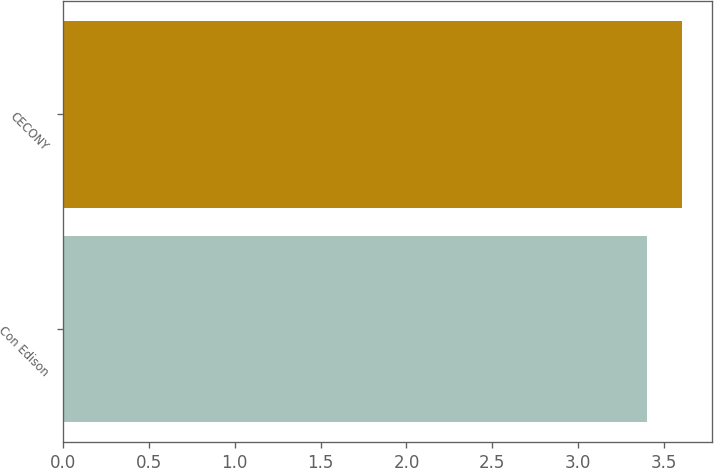Convert chart to OTSL. <chart><loc_0><loc_0><loc_500><loc_500><bar_chart><fcel>Con Edison<fcel>CECONY<nl><fcel>3.4<fcel>3.6<nl></chart> 